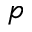Convert formula to latex. <formula><loc_0><loc_0><loc_500><loc_500>p</formula> 